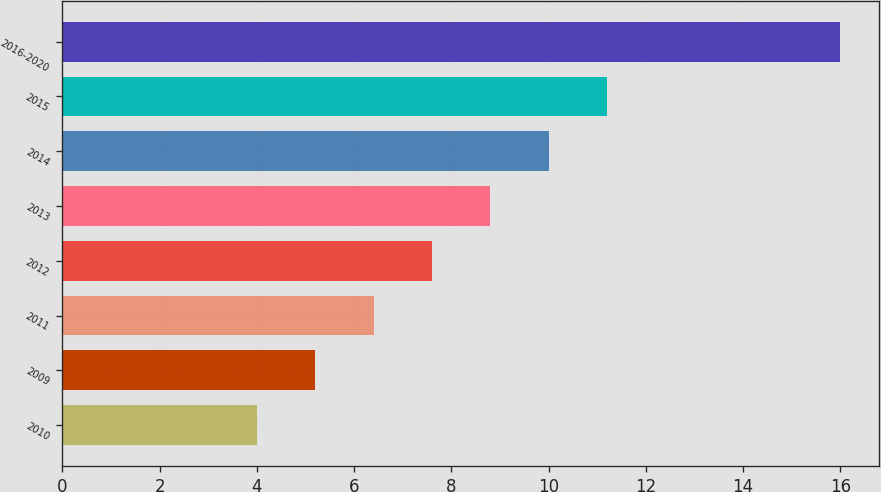Convert chart to OTSL. <chart><loc_0><loc_0><loc_500><loc_500><bar_chart><fcel>2010<fcel>2009<fcel>2011<fcel>2012<fcel>2013<fcel>2014<fcel>2015<fcel>2016-2020<nl><fcel>4<fcel>5.2<fcel>6.4<fcel>7.6<fcel>8.8<fcel>10<fcel>11.2<fcel>16<nl></chart> 